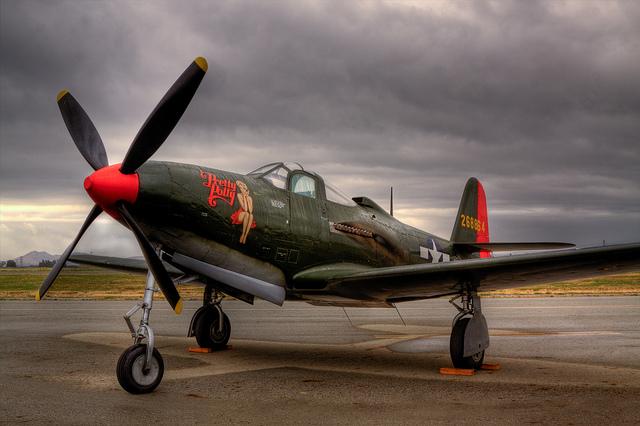What image is on the plane?
Keep it brief. Woman. How are the skies?
Quick response, please. Cloudy. Is this a propeller or jet plane?
Write a very short answer. Propeller. 